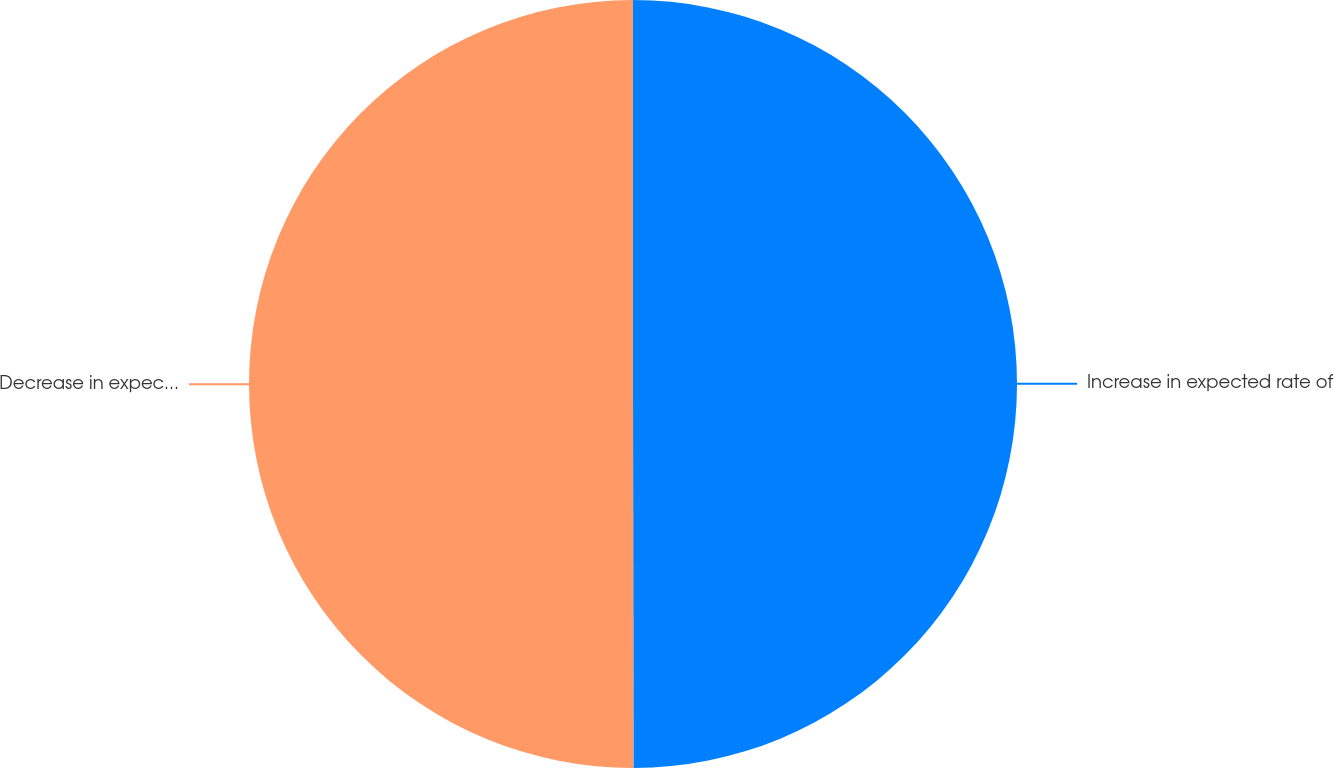Convert chart. <chart><loc_0><loc_0><loc_500><loc_500><pie_chart><fcel>Increase in expected rate of<fcel>Decrease in expected rate of<nl><fcel>49.98%<fcel>50.02%<nl></chart> 